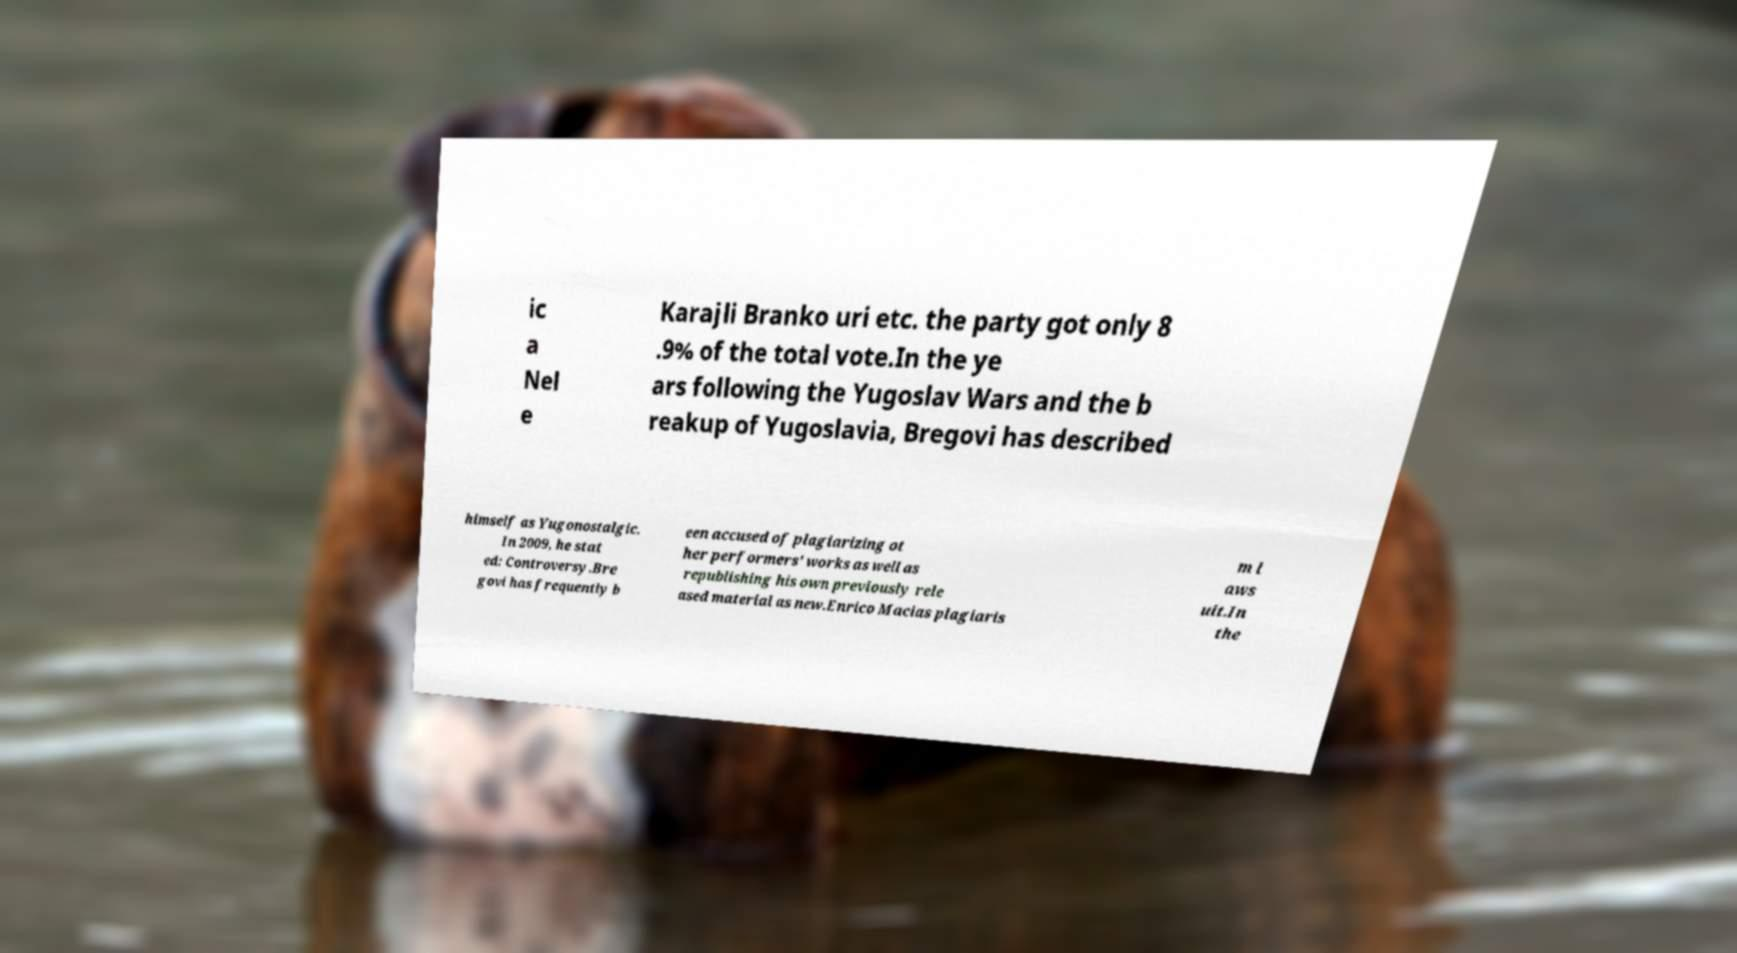Could you assist in decoding the text presented in this image and type it out clearly? ic a Nel e Karajli Branko uri etc. the party got only 8 .9% of the total vote.In the ye ars following the Yugoslav Wars and the b reakup of Yugoslavia, Bregovi has described himself as Yugonostalgic. In 2009, he stat ed: Controversy.Bre govi has frequently b een accused of plagiarizing ot her performers' works as well as republishing his own previously rele ased material as new.Enrico Macias plagiaris m l aws uit.In the 